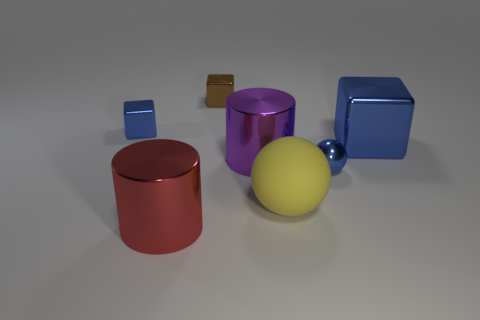Subtract all tiny blue shiny blocks. How many blocks are left? 2 Add 2 large yellow balls. How many objects exist? 9 Subtract all blue cubes. How many cubes are left? 1 Subtract all brown cylinders. How many blue cubes are left? 2 Subtract all cylinders. How many objects are left? 5 Subtract 1 blocks. How many blocks are left? 2 Subtract all tiny brown blocks. Subtract all big purple shiny spheres. How many objects are left? 6 Add 2 big cylinders. How many big cylinders are left? 4 Add 7 big spheres. How many big spheres exist? 8 Subtract 0 cyan balls. How many objects are left? 7 